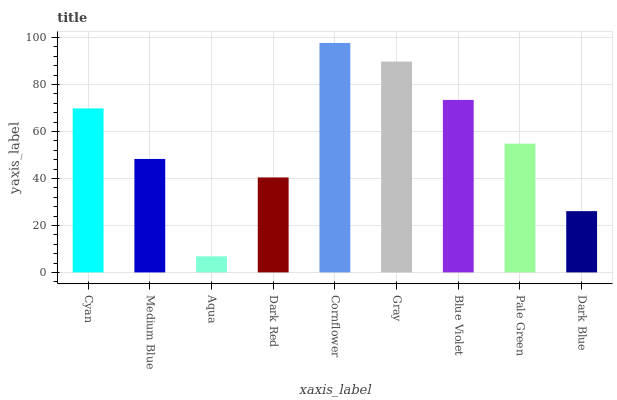Is Aqua the minimum?
Answer yes or no. Yes. Is Cornflower the maximum?
Answer yes or no. Yes. Is Medium Blue the minimum?
Answer yes or no. No. Is Medium Blue the maximum?
Answer yes or no. No. Is Cyan greater than Medium Blue?
Answer yes or no. Yes. Is Medium Blue less than Cyan?
Answer yes or no. Yes. Is Medium Blue greater than Cyan?
Answer yes or no. No. Is Cyan less than Medium Blue?
Answer yes or no. No. Is Pale Green the high median?
Answer yes or no. Yes. Is Pale Green the low median?
Answer yes or no. Yes. Is Gray the high median?
Answer yes or no. No. Is Cyan the low median?
Answer yes or no. No. 